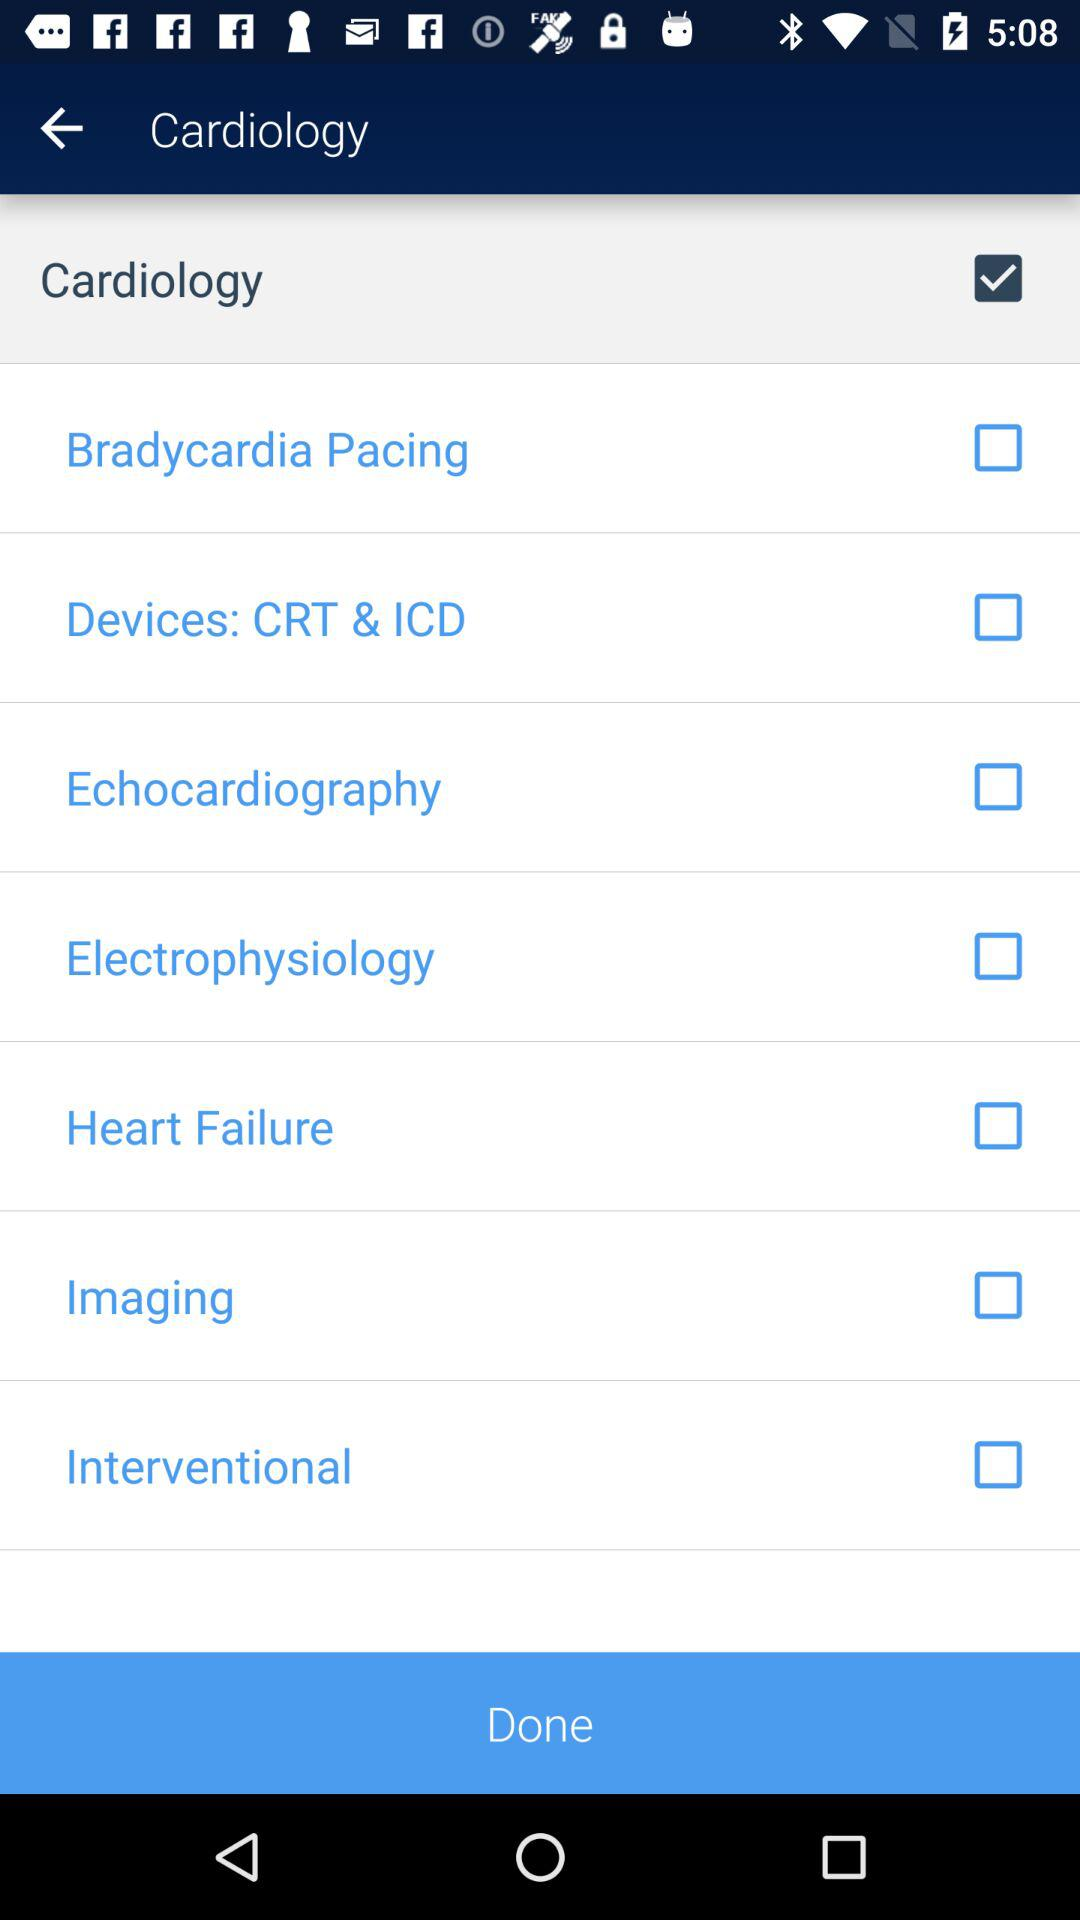How many checkboxes are unchecked?
Answer the question using a single word or phrase. 7 